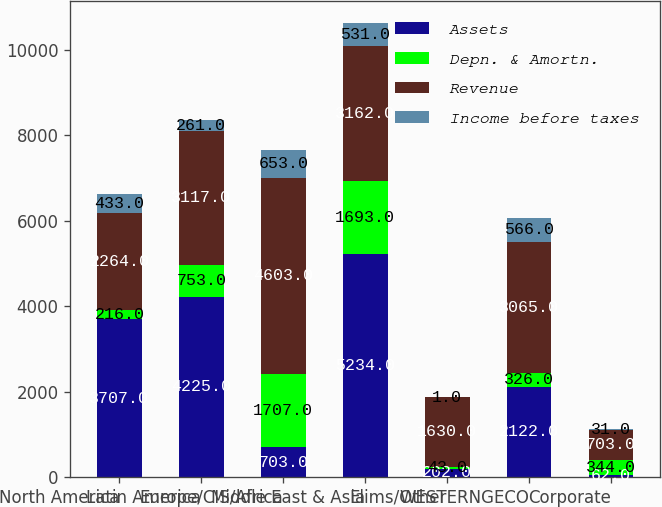Convert chart to OTSL. <chart><loc_0><loc_0><loc_500><loc_500><stacked_bar_chart><ecel><fcel>North America<fcel>Latin America<fcel>Europe/CIS/Africa<fcel>Middle East & Asia<fcel>Elims/Other<fcel>WESTERNGECO<fcel>Corporate<nl><fcel>Assets<fcel>3707<fcel>4225<fcel>703<fcel>5234<fcel>202<fcel>2122<fcel>62<nl><fcel>Depn. & Amortn.<fcel>216<fcel>753<fcel>1707<fcel>1693<fcel>43<fcel>326<fcel>344<nl><fcel>Revenue<fcel>2264<fcel>3117<fcel>4603<fcel>3162<fcel>1630<fcel>3065<fcel>703<nl><fcel>Income before taxes<fcel>433<fcel>261<fcel>653<fcel>531<fcel>1<fcel>566<fcel>31<nl></chart> 